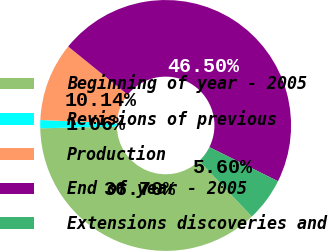Convert chart. <chart><loc_0><loc_0><loc_500><loc_500><pie_chart><fcel>Beginning of year - 2005<fcel>Revisions of previous<fcel>Production<fcel>End of year - 2005<fcel>Extensions discoveries and<nl><fcel>36.7%<fcel>1.06%<fcel>10.14%<fcel>46.5%<fcel>5.6%<nl></chart> 